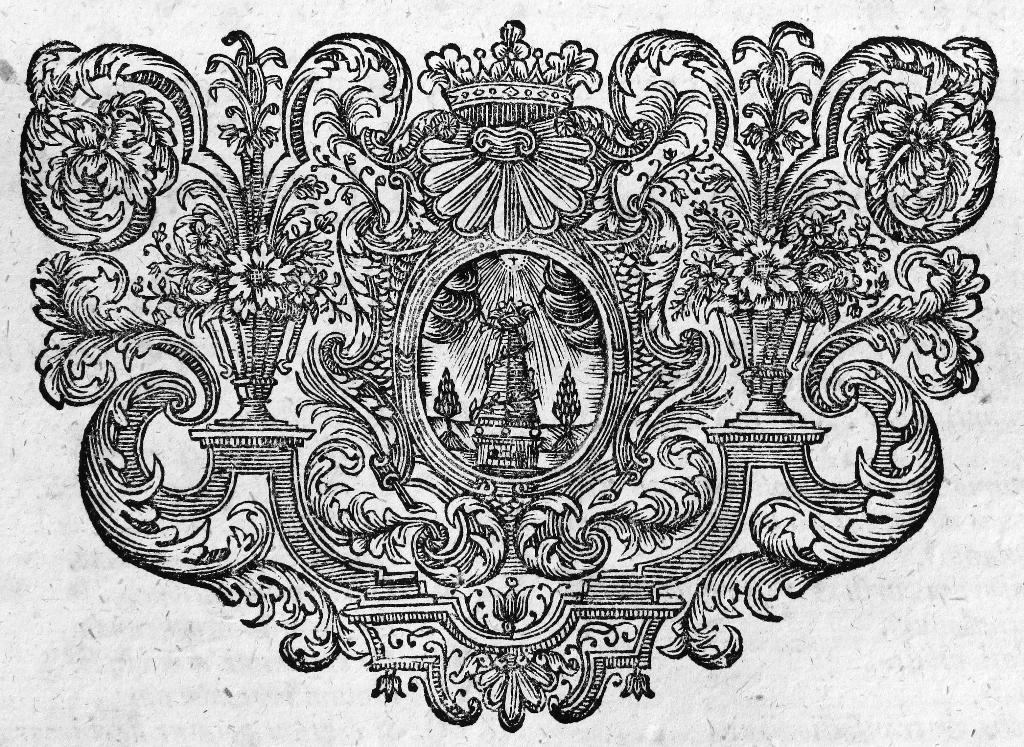What is present in the image? There is a paper in the image. What is depicted on the paper? The paper contains plants and flowers. What type of trade is being conducted in the image? There is no indication of any trade being conducted in the image; it only features a paper with plants and flowers. Can you describe the girl in the image? There is no girl present in the image; it only features a paper with plants and flowers. 